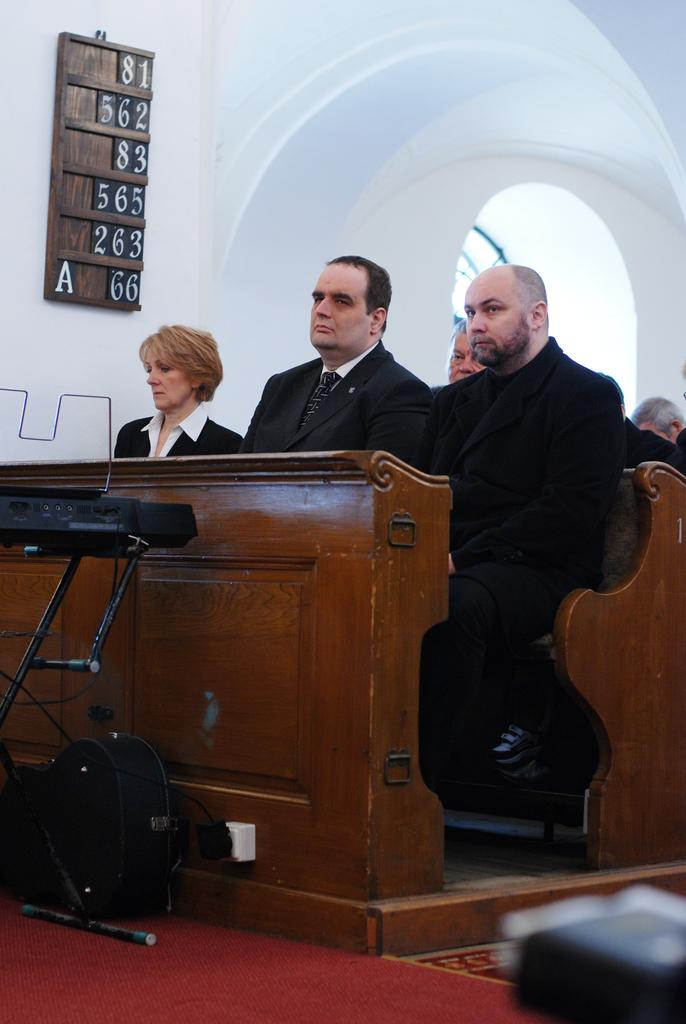What are the people in the image doing? There are persons sitting on a bench in the image. What is in front of the bench? There is a table in front of the bench. What can be seen behind the bench? There is a white wall in the background. Is there any way to access the area behind the white wall? Yes, there is an entrance for the white wall in the background. What is the level of disgust expressed by the persons sitting on the bench in the image? There is no indication of any emotion, including disgust, being expressed by the persons sitting on the bench in the image. 